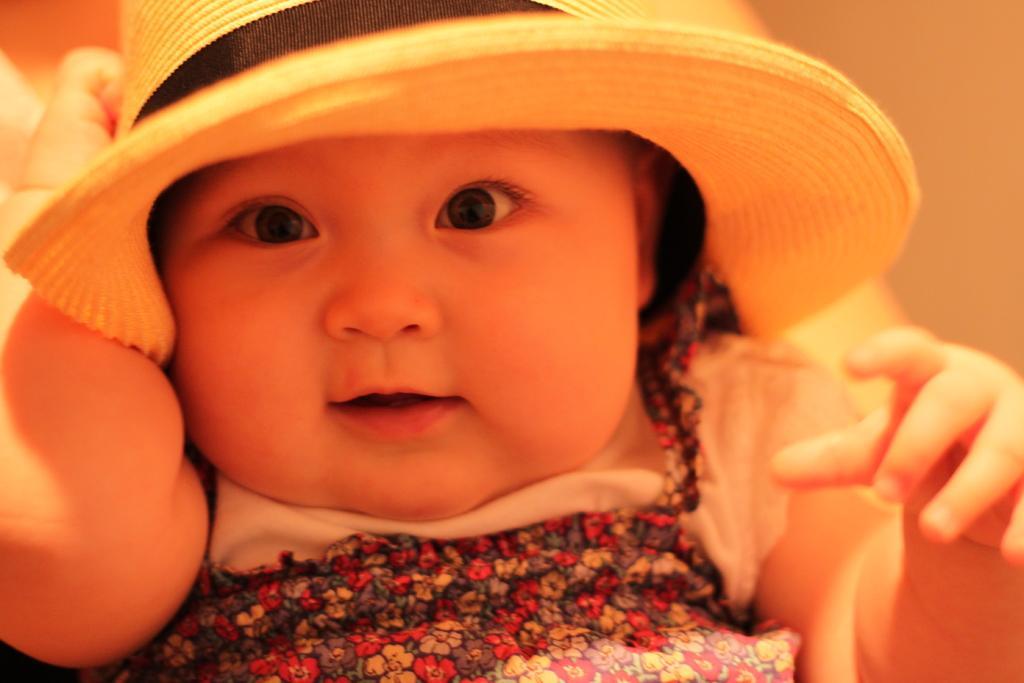Could you give a brief overview of what you see in this image? In this picture I can observe a baby. The baby is wearing a hat on her head. The background is blurred. 